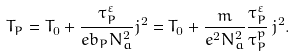<formula> <loc_0><loc_0><loc_500><loc_500>T _ { P } = T _ { 0 } + \frac { \tau _ { P } ^ { \varepsilon } } { e b _ { P } N _ { a } ^ { 2 } } j ^ { 2 } = T _ { 0 } + \frac { m } { e ^ { 2 } N _ { a } ^ { 2 } } \frac { \tau _ { P } ^ { \varepsilon } } { \tau _ { P } ^ { p } } \, j ^ { 2 } .</formula> 